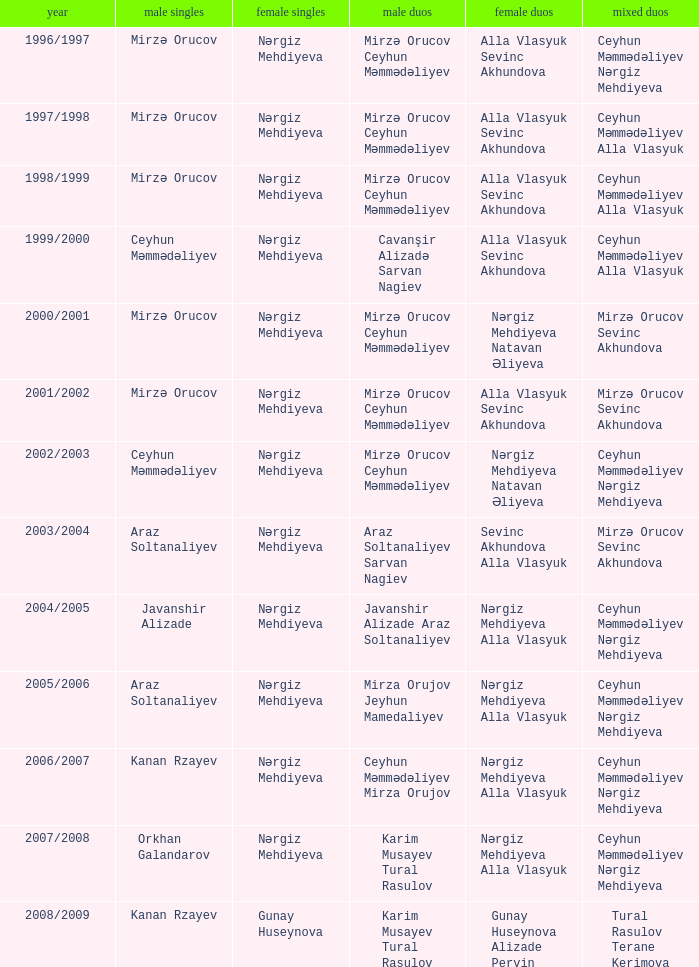Who were all womens doubles for the year 2000/2001? Nərgiz Mehdiyeva Natavan Əliyeva. Parse the table in full. {'header': ['year', 'male singles', 'female singles', 'male duos', 'female duos', 'mixed duos'], 'rows': [['1996/1997', 'Mirzə Orucov', 'Nərgiz Mehdiyeva', 'Mirzə Orucov Ceyhun Məmmədəliyev', 'Alla Vlasyuk Sevinc Akhundova', 'Ceyhun Məmmədəliyev Nərgiz Mehdiyeva'], ['1997/1998', 'Mirzə Orucov', 'Nərgiz Mehdiyeva', 'Mirzə Orucov Ceyhun Məmmədəliyev', 'Alla Vlasyuk Sevinc Akhundova', 'Ceyhun Məmmədəliyev Alla Vlasyuk'], ['1998/1999', 'Mirzə Orucov', 'Nərgiz Mehdiyeva', 'Mirzə Orucov Ceyhun Məmmədəliyev', 'Alla Vlasyuk Sevinc Akhundova', 'Ceyhun Məmmədəliyev Alla Vlasyuk'], ['1999/2000', 'Ceyhun Məmmədəliyev', 'Nərgiz Mehdiyeva', 'Cavanşir Alizadə Sarvan Nagiev', 'Alla Vlasyuk Sevinc Akhundova', 'Ceyhun Məmmədəliyev Alla Vlasyuk'], ['2000/2001', 'Mirzə Orucov', 'Nərgiz Mehdiyeva', 'Mirzə Orucov Ceyhun Məmmədəliyev', 'Nərgiz Mehdiyeva Natavan Əliyeva', 'Mirzə Orucov Sevinc Akhundova'], ['2001/2002', 'Mirzə Orucov', 'Nərgiz Mehdiyeva', 'Mirzə Orucov Ceyhun Məmmədəliyev', 'Alla Vlasyuk Sevinc Akhundova', 'Mirzə Orucov Sevinc Akhundova'], ['2002/2003', 'Ceyhun Məmmədəliyev', 'Nərgiz Mehdiyeva', 'Mirzə Orucov Ceyhun Məmmədəliyev', 'Nərgiz Mehdiyeva Natavan Əliyeva', 'Ceyhun Məmmədəliyev Nərgiz Mehdiyeva'], ['2003/2004', 'Araz Soltanaliyev', 'Nərgiz Mehdiyeva', 'Araz Soltanaliyev Sarvan Nagiev', 'Sevinc Akhundova Alla Vlasyuk', 'Mirzə Orucov Sevinc Akhundova'], ['2004/2005', 'Javanshir Alizade', 'Nərgiz Mehdiyeva', 'Javanshir Alizade Araz Soltanaliyev', 'Nərgiz Mehdiyeva Alla Vlasyuk', 'Ceyhun Məmmədəliyev Nərgiz Mehdiyeva'], ['2005/2006', 'Araz Soltanaliyev', 'Nərgiz Mehdiyeva', 'Mirza Orujov Jeyhun Mamedaliyev', 'Nərgiz Mehdiyeva Alla Vlasyuk', 'Ceyhun Məmmədəliyev Nərgiz Mehdiyeva'], ['2006/2007', 'Kanan Rzayev', 'Nərgiz Mehdiyeva', 'Ceyhun Məmmədəliyev Mirza Orujov', 'Nərgiz Mehdiyeva Alla Vlasyuk', 'Ceyhun Məmmədəliyev Nərgiz Mehdiyeva'], ['2007/2008', 'Orkhan Galandarov', 'Nərgiz Mehdiyeva', 'Karim Musayev Tural Rasulov', 'Nərgiz Mehdiyeva Alla Vlasyuk', 'Ceyhun Məmmədəliyev Nərgiz Mehdiyeva'], ['2008/2009', 'Kanan Rzayev', 'Gunay Huseynova', 'Karim Musayev Tural Rasulov', 'Gunay Huseynova Alizade Pervin', 'Tural Rasulov Terane Kerimova']]} 